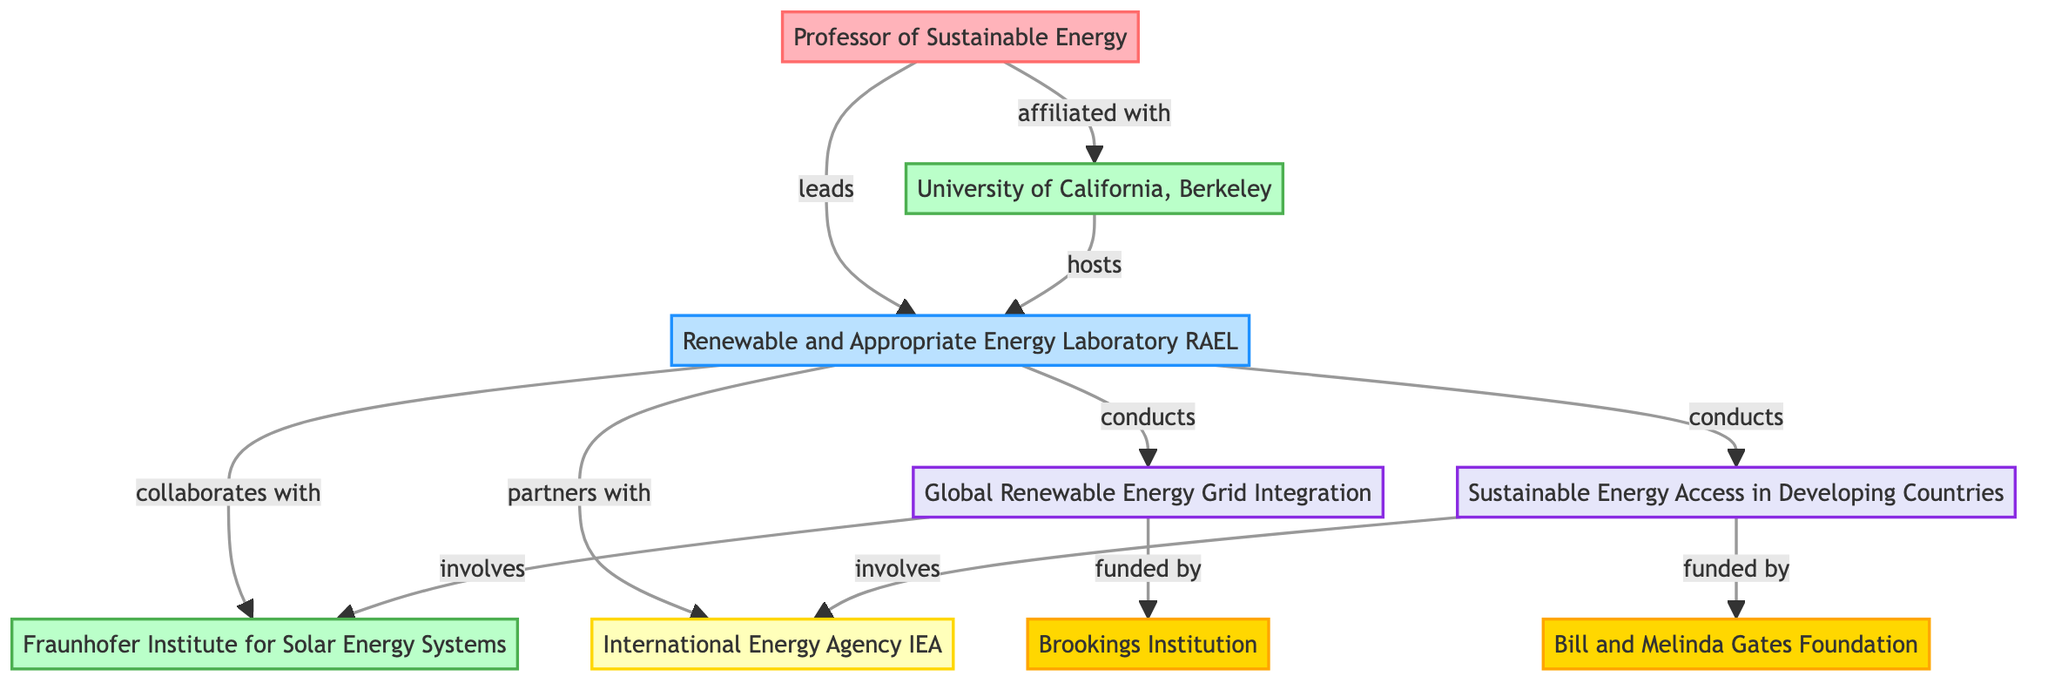What is the total number of nodes in the diagram? The diagram consists of 8 nodes: Professor of Sustainable Energy, University of California, Berkeley, Renewable and Appropriate Energy Laboratory (RAEL), Fraunhofer Institute for Solar Energy Systems, International Energy Agency (IEA), Global Renewable Energy Grid Integration, Sustainable Energy Access in Developing Countries, Brookings Institution, and Bill and Melinda Gates Foundation.
Answer: 8 Which institution is the professor affiliated with? The edge labeled "affiliated with" connects the professor to the University of California, Berkeley, showing that this is the institution the professor is part of.
Answer: University of California, Berkeley How many projects are conducted by the research group? The research group "Renewable and Appropriate Energy Laboratory (RAEL)" conducts two projects as indicated by the two edges labeled "conducts" leading to the projects.
Answer: 2 What organization does the research group partner with? The edge labeled "partners with" connects the research group to the International Energy Agency, indicating that this is the organization the research group collaborates with.
Answer: International Energy Agency (IEA) Which funding agency supports the project on Sustainable Energy Access in Developing Countries? The edge labeled "funded by" leads from the project "Sustainable Energy Access in Developing Countries" to the Bill and Melinda Gates Foundation, indicating that this is the funding agency for that project.
Answer: Bill and Melinda Gates Foundation What type of collaboration exists between the research group and the Fraunhofer Institute? The relationship is shown by the edge labeled "collaborates with," indicating that the research group works in collaboration with the Fraunhofer Institute for Solar Energy Systems.
Answer: collaborates with Which project involves the Fraunhofer Institute for Solar Energy Systems? The edge labeled "involves" from the project "Global Renewable Energy Grid Integration" connects to the Fraunhofer Institute for Solar Energy Systems, indicating the involvement of this institution in that project.
Answer: Global Renewable Energy Grid Integration What is the relationship between the professor and the research group? The diagram shows an edge labeled "leads" from the professor to the research group, indicating that the professor is in a leadership role within this research group.
Answer: leads 